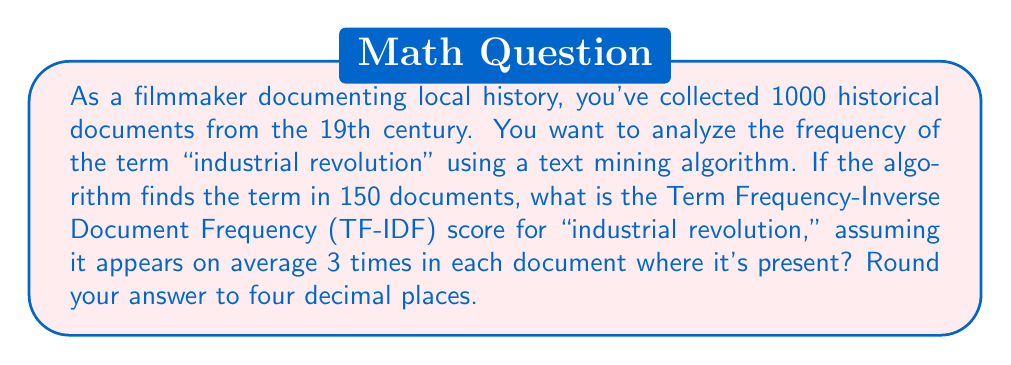Provide a solution to this math problem. To calculate the TF-IDF score, we need to follow these steps:

1. Calculate Term Frequency (TF):
   TF = (Average number of times the term appears in a document) / (Total number of words in the document)
   We're given that the term appears on average 3 times in each document where it's present. Let's assume an average document length of 1000 words.
   
   $$ TF = \frac{3}{1000} = 0.003 $$

2. Calculate Inverse Document Frequency (IDF):
   IDF = $\log(\frac{\text{Total number of documents}}{\text{Number of documents containing the term}})$
   
   $$ IDF = \log(\frac{1000}{150}) = \log(6.6667) \approx 1.8971 $$

3. Calculate TF-IDF:
   TF-IDF = TF * IDF
   
   $$ TF-IDF = 0.003 * 1.8971 = 0.0057 $$

4. Round to four decimal places:
   0.0057 rounded to four decimal places is 0.0057.

This TF-IDF score represents the importance of the term "industrial revolution" in the collection of historical documents. A higher score indicates that the term is more relevant and specific to certain documents in the collection.
Answer: 0.0057 